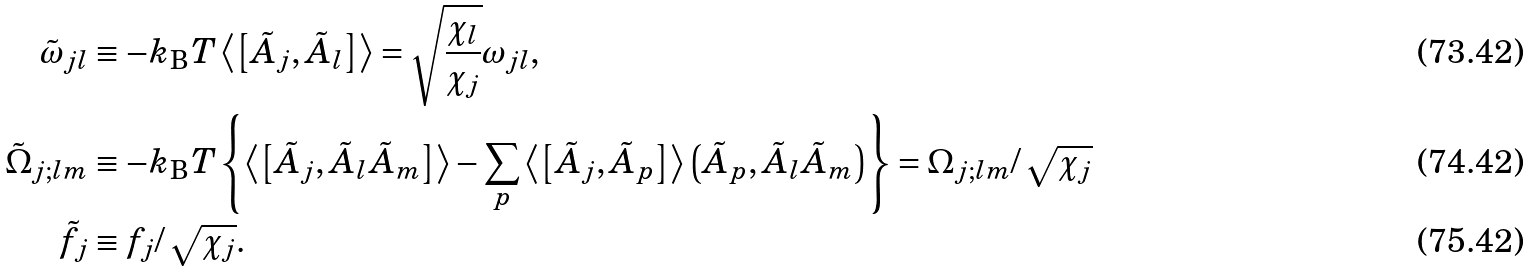Convert formula to latex. <formula><loc_0><loc_0><loc_500><loc_500>\tilde { \omega } _ { j l } & \equiv - k _ { \text  B}T \left\langle\left[ \tilde{A}_{j},\tilde{A}_{l} \right]\right\rangle =\sqrt{\frac{\chi_{l}} { \chi _ { j } } } \omega _ { j l } , \\ \tilde { \Omega } _ { j ; l m } & \equiv - k _ { \text  B}T \left\{ \left\langle\left[ \tilde{A}_{j}, \tilde{A}_{l}\tilde{A}_{m} \right]\right\rangle -\sum_{p}\left\langle\left[ \tilde{A}_{j}, \tilde{A}_{p} \right]\right\rangle \left(\tilde{A}_{p}, \tilde{A}_{l}\tilde{A}_{m} \right) \right\} =\Omega_{j;lm}/\,\sqrt{\chi_{j} } \\ \tilde { f } _ { j } & \equiv f _ { j } / \, \sqrt { \chi _ { j } } .</formula> 